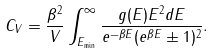<formula> <loc_0><loc_0><loc_500><loc_500>C _ { V } = \frac { \beta ^ { 2 } } { V } \int _ { E _ { \min } } ^ { \infty } \frac { g ( E ) E ^ { 2 } d E } { e ^ { - \beta E } ( e ^ { \beta E } \pm 1 ) ^ { 2 } } .</formula> 